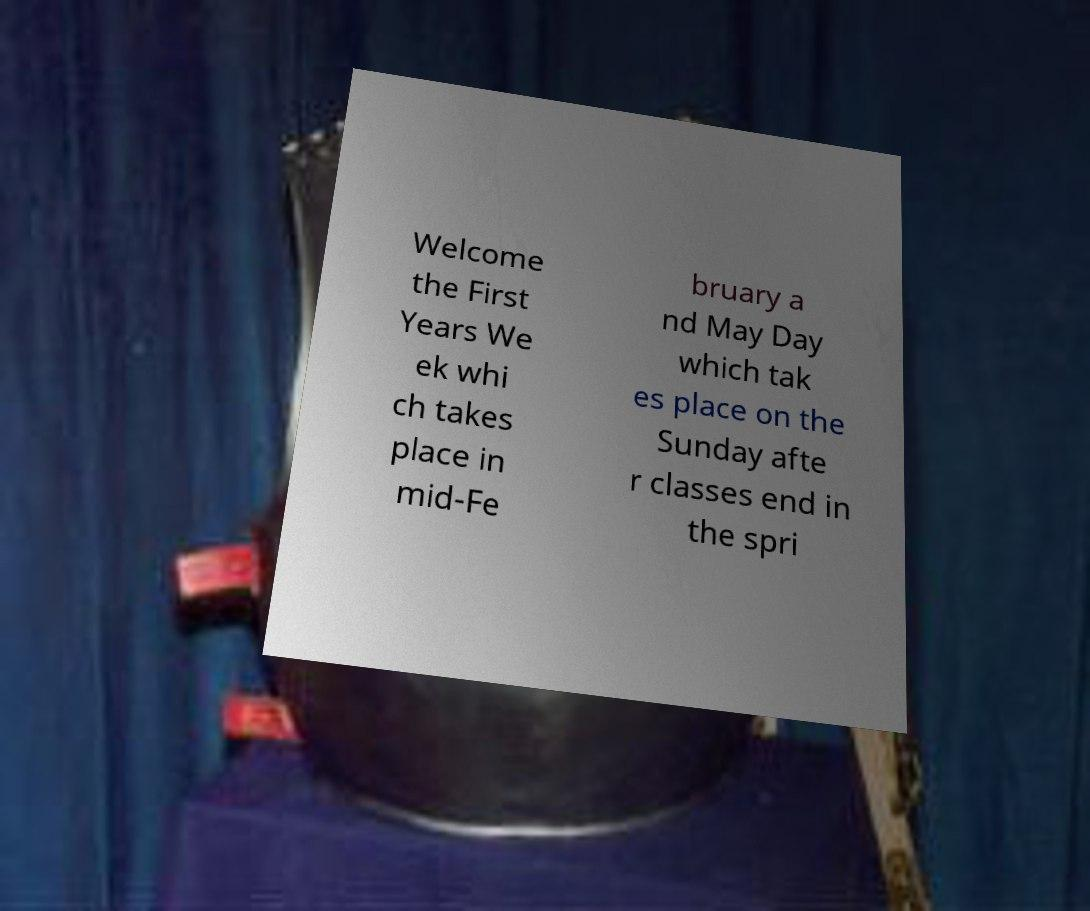Please identify and transcribe the text found in this image. Welcome the First Years We ek whi ch takes place in mid-Fe bruary a nd May Day which tak es place on the Sunday afte r classes end in the spri 